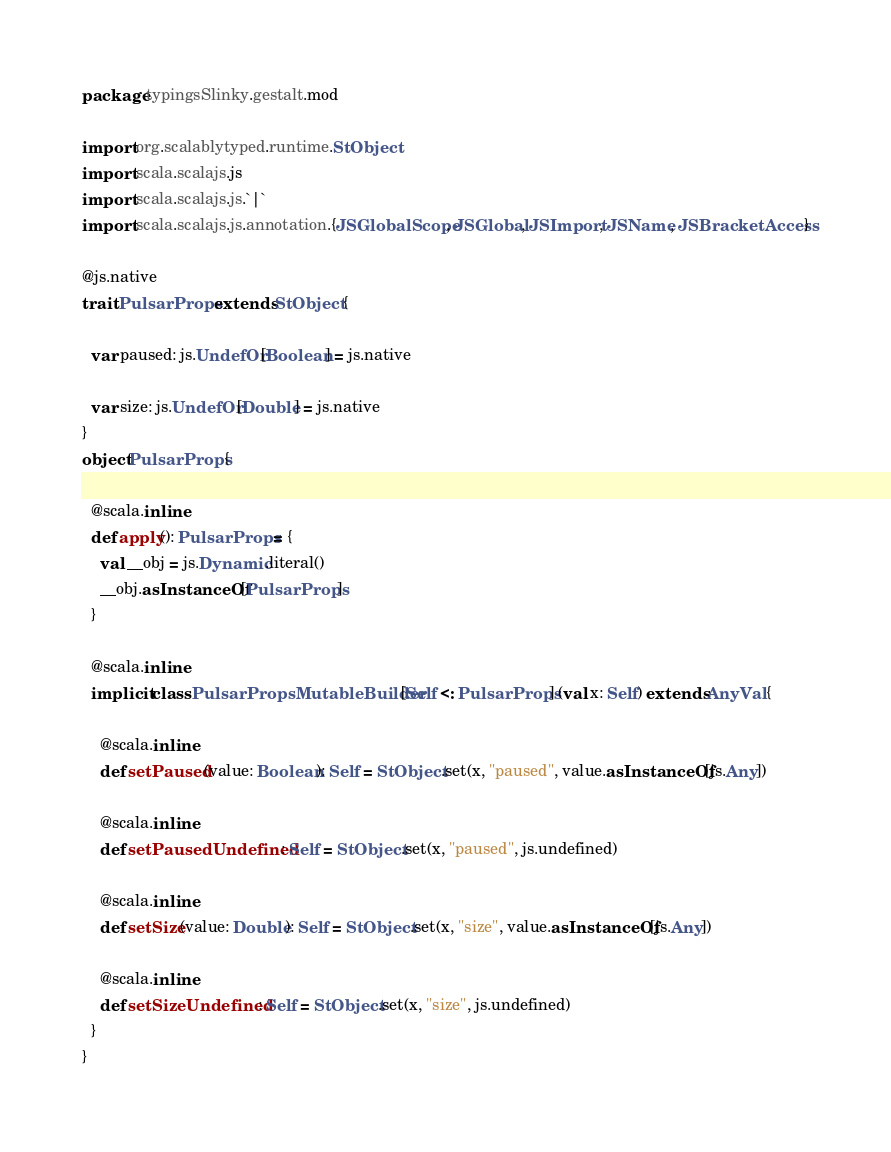Convert code to text. <code><loc_0><loc_0><loc_500><loc_500><_Scala_>package typingsSlinky.gestalt.mod

import org.scalablytyped.runtime.StObject
import scala.scalajs.js
import scala.scalajs.js.`|`
import scala.scalajs.js.annotation.{JSGlobalScope, JSGlobal, JSImport, JSName, JSBracketAccess}

@js.native
trait PulsarProps extends StObject {
  
  var paused: js.UndefOr[Boolean] = js.native
  
  var size: js.UndefOr[Double] = js.native
}
object PulsarProps {
  
  @scala.inline
  def apply(): PulsarProps = {
    val __obj = js.Dynamic.literal()
    __obj.asInstanceOf[PulsarProps]
  }
  
  @scala.inline
  implicit class PulsarPropsMutableBuilder[Self <: PulsarProps] (val x: Self) extends AnyVal {
    
    @scala.inline
    def setPaused(value: Boolean): Self = StObject.set(x, "paused", value.asInstanceOf[js.Any])
    
    @scala.inline
    def setPausedUndefined: Self = StObject.set(x, "paused", js.undefined)
    
    @scala.inline
    def setSize(value: Double): Self = StObject.set(x, "size", value.asInstanceOf[js.Any])
    
    @scala.inline
    def setSizeUndefined: Self = StObject.set(x, "size", js.undefined)
  }
}
</code> 